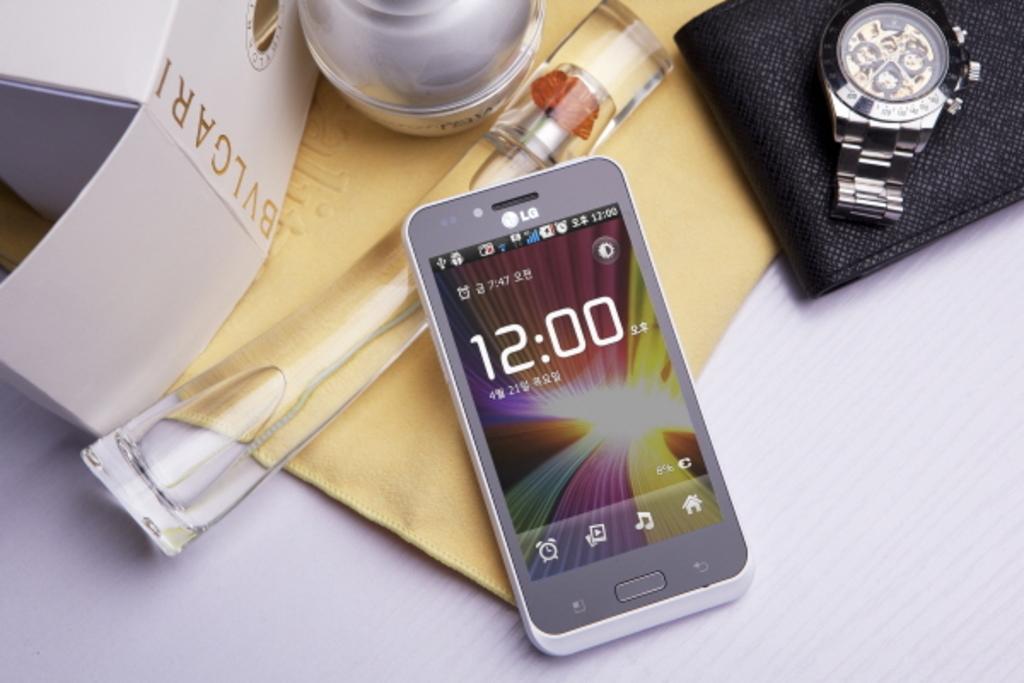What time does the phone read?
Give a very brief answer. 12:00. What phone brand is this?
Provide a short and direct response. Lg. 